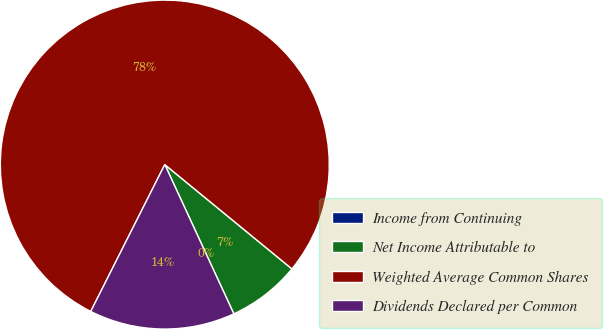Convert chart. <chart><loc_0><loc_0><loc_500><loc_500><pie_chart><fcel>Income from Continuing<fcel>Net Income Attributable to<fcel>Weighted Average Common Shares<fcel>Dividends Declared per Common<nl><fcel>0.0%<fcel>7.17%<fcel>78.5%<fcel>14.33%<nl></chart> 